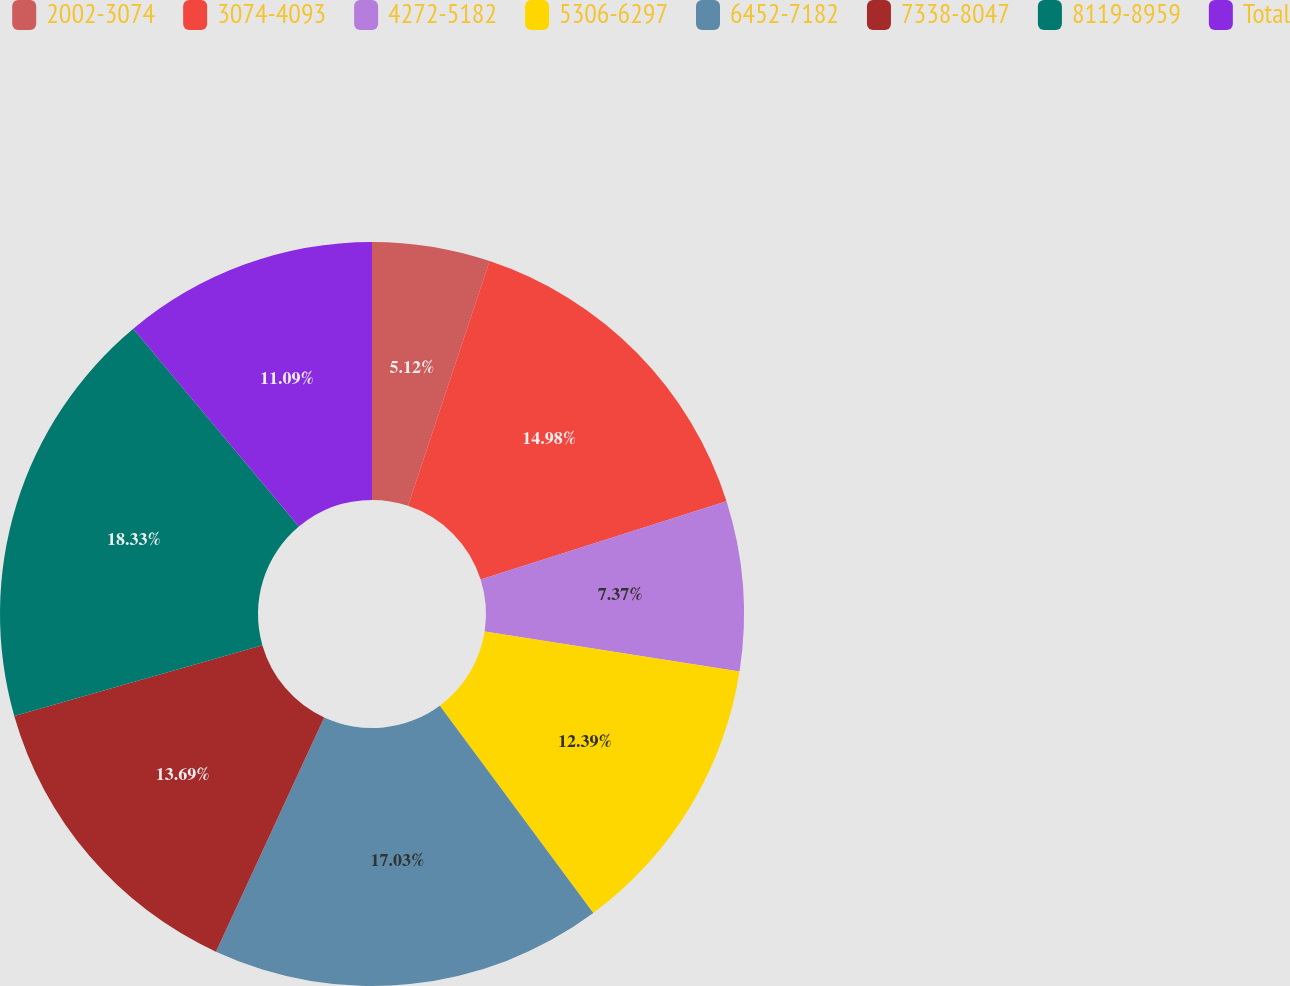<chart> <loc_0><loc_0><loc_500><loc_500><pie_chart><fcel>2002-3074<fcel>3074-4093<fcel>4272-5182<fcel>5306-6297<fcel>6452-7182<fcel>7338-8047<fcel>8119-8959<fcel>Total<nl><fcel>5.12%<fcel>14.98%<fcel>7.37%<fcel>12.39%<fcel>17.03%<fcel>13.69%<fcel>18.33%<fcel>11.09%<nl></chart> 